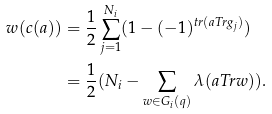<formula> <loc_0><loc_0><loc_500><loc_500>w ( c ( a ) ) & = \frac { 1 } { 2 } \sum _ { j = 1 } ^ { N _ { i } } ( 1 - ( - 1 ) ^ { t r ( a T r g _ { j } ) } ) \\ & = \frac { 1 } { 2 } ( N _ { i } - \sum _ { w \in G _ { i } ( q ) } \lambda ( a T r w ) ) .</formula> 